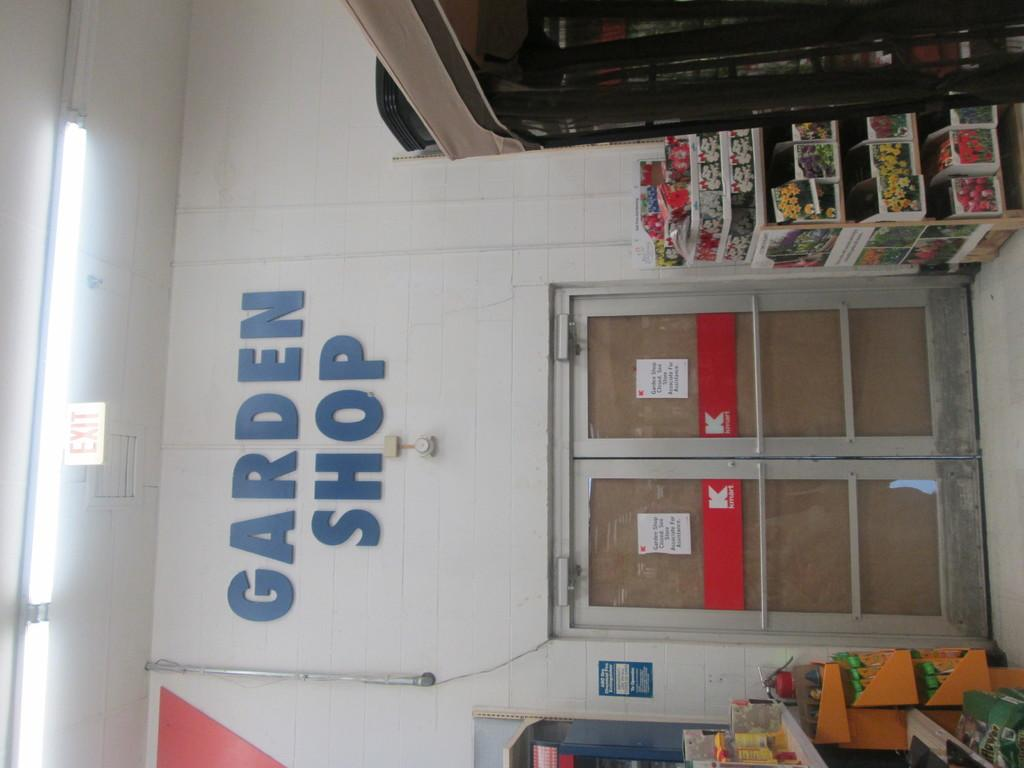<image>
Describe the image concisely. A set of double doors with a red K on them has the Garden shop on top of the doors. 